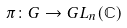<formula> <loc_0><loc_0><loc_500><loc_500>\pi \colon G \to G L _ { n } ( \mathbb { C } )</formula> 